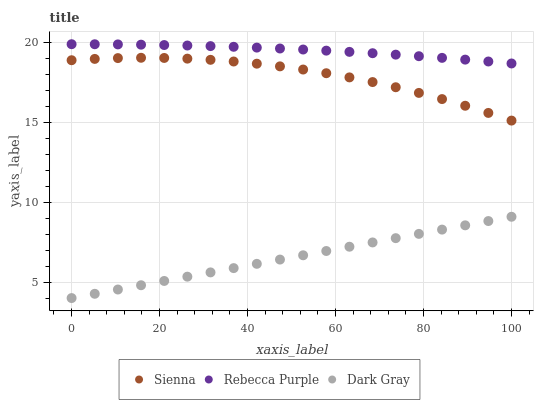Does Dark Gray have the minimum area under the curve?
Answer yes or no. Yes. Does Rebecca Purple have the maximum area under the curve?
Answer yes or no. Yes. Does Rebecca Purple have the minimum area under the curve?
Answer yes or no. No. Does Dark Gray have the maximum area under the curve?
Answer yes or no. No. Is Dark Gray the smoothest?
Answer yes or no. Yes. Is Sienna the roughest?
Answer yes or no. Yes. Is Rebecca Purple the smoothest?
Answer yes or no. No. Is Rebecca Purple the roughest?
Answer yes or no. No. Does Dark Gray have the lowest value?
Answer yes or no. Yes. Does Rebecca Purple have the lowest value?
Answer yes or no. No. Does Rebecca Purple have the highest value?
Answer yes or no. Yes. Does Dark Gray have the highest value?
Answer yes or no. No. Is Sienna less than Rebecca Purple?
Answer yes or no. Yes. Is Rebecca Purple greater than Sienna?
Answer yes or no. Yes. Does Sienna intersect Rebecca Purple?
Answer yes or no. No. 